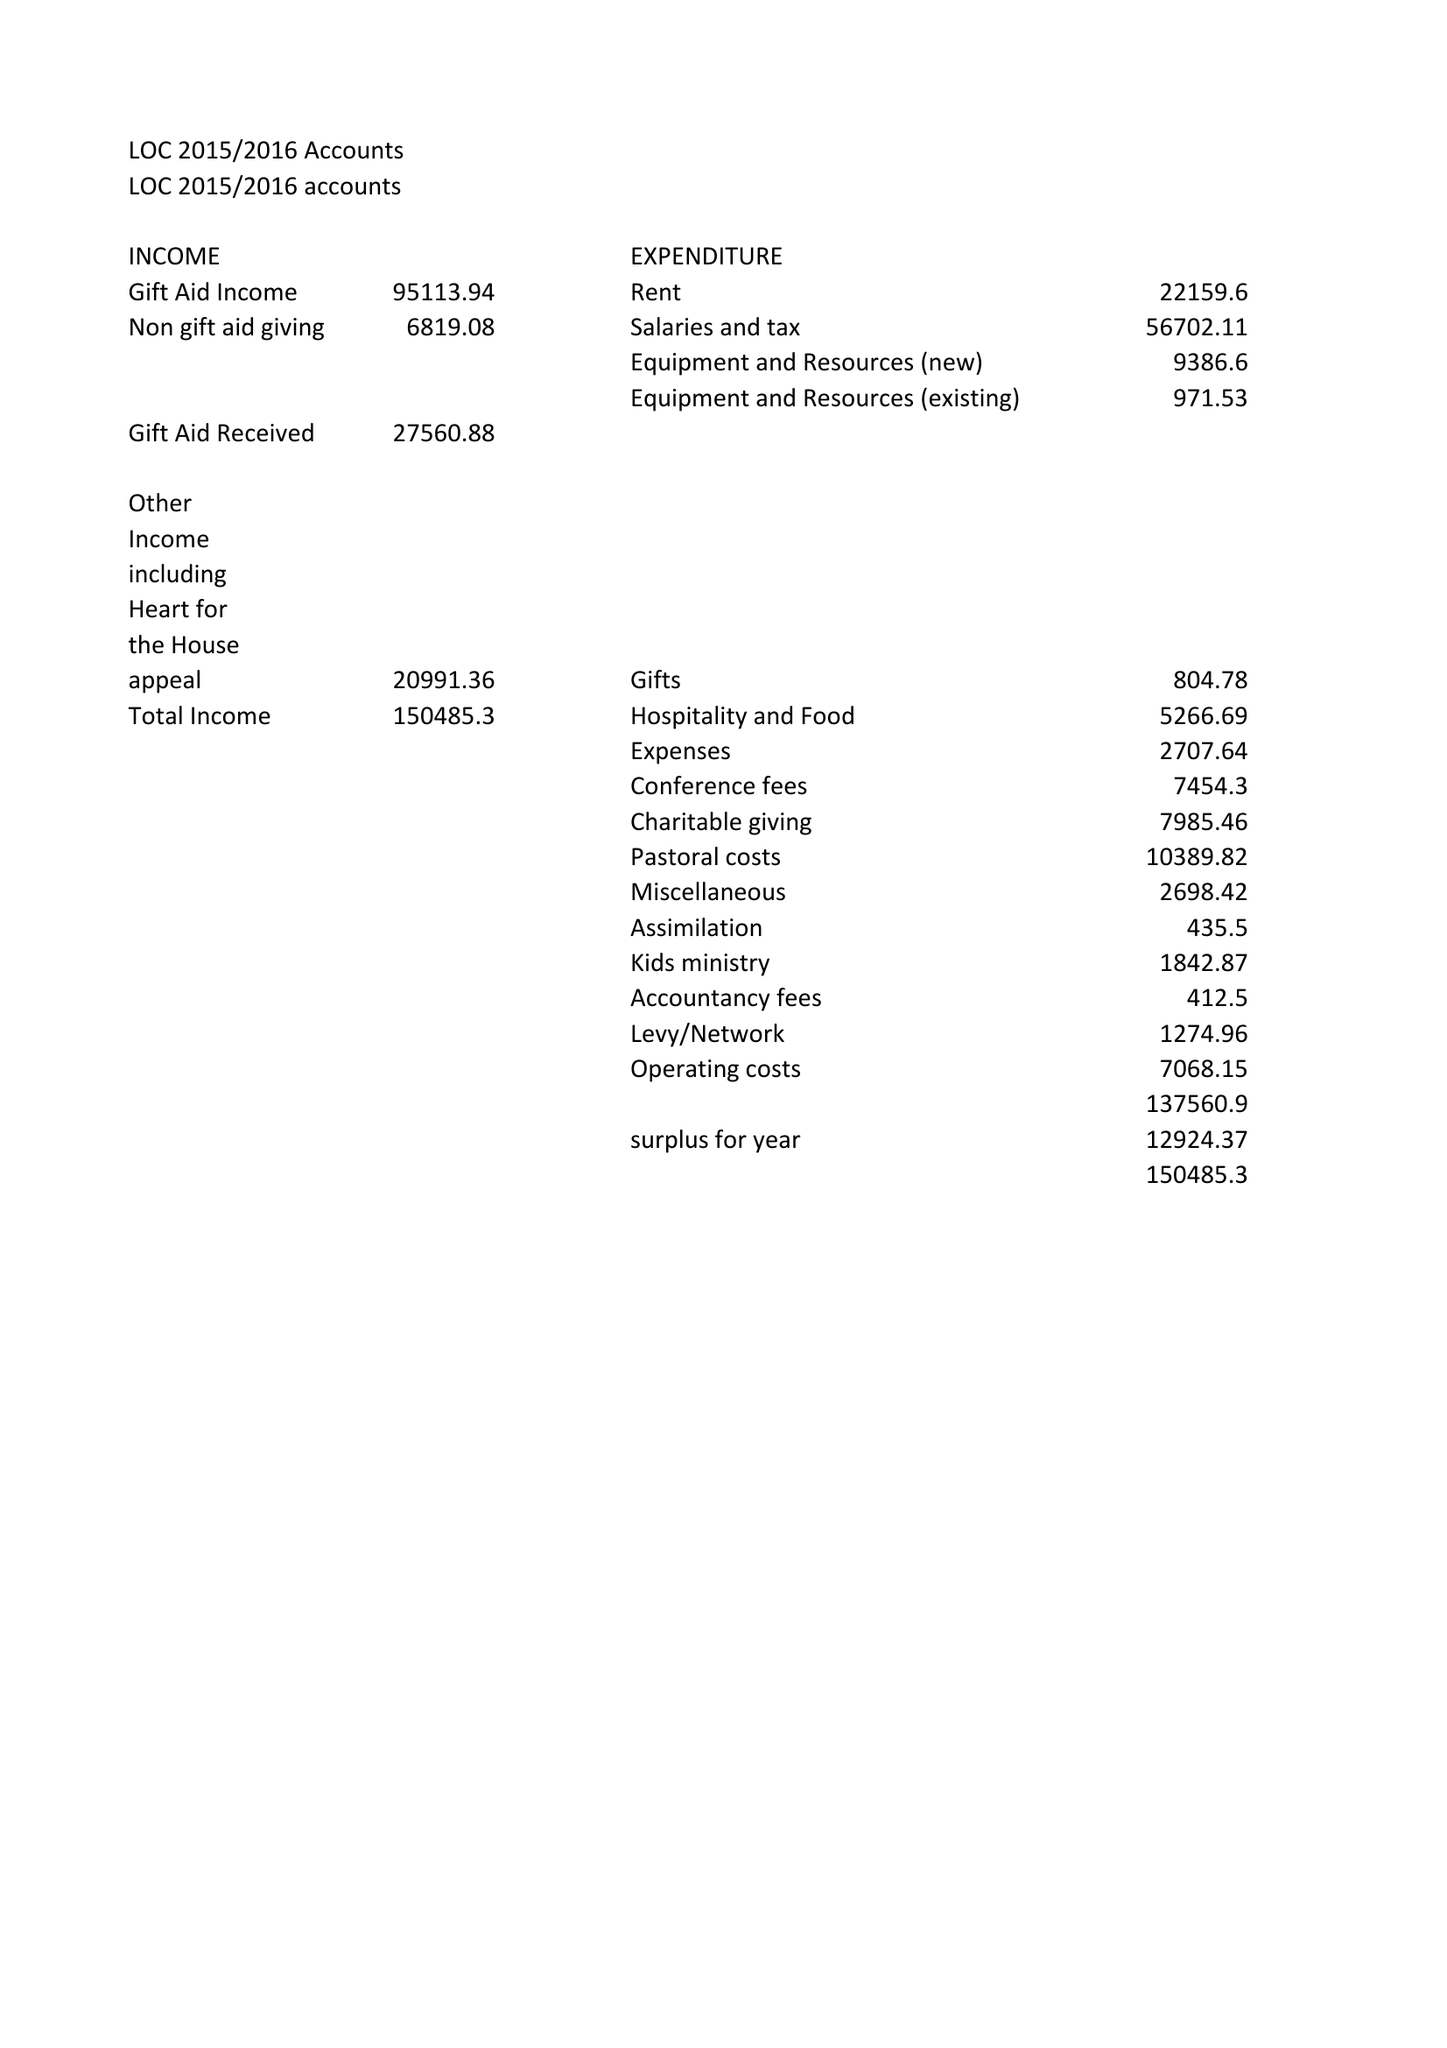What is the value for the income_annually_in_british_pounds?
Answer the question using a single word or phrase. 150485.30 